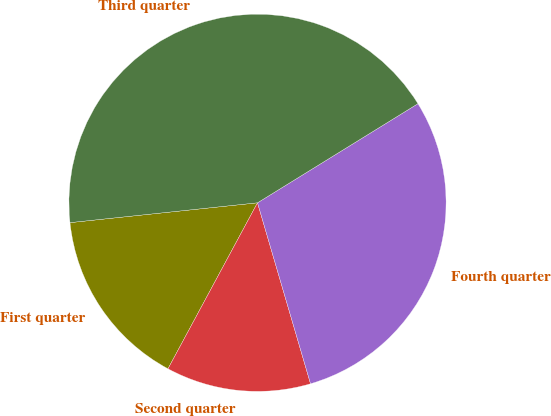<chart> <loc_0><loc_0><loc_500><loc_500><pie_chart><fcel>First quarter<fcel>Second quarter<fcel>Fourth quarter<fcel>Third quarter<nl><fcel>15.45%<fcel>12.41%<fcel>29.27%<fcel>42.87%<nl></chart> 